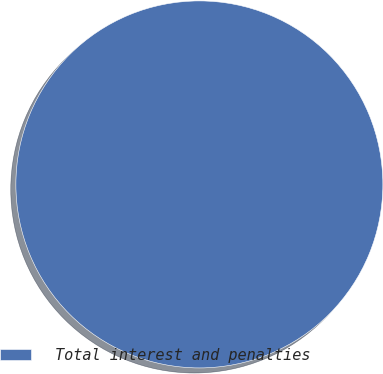<chart> <loc_0><loc_0><loc_500><loc_500><pie_chart><fcel>Total interest and penalties<nl><fcel>100.0%<nl></chart> 